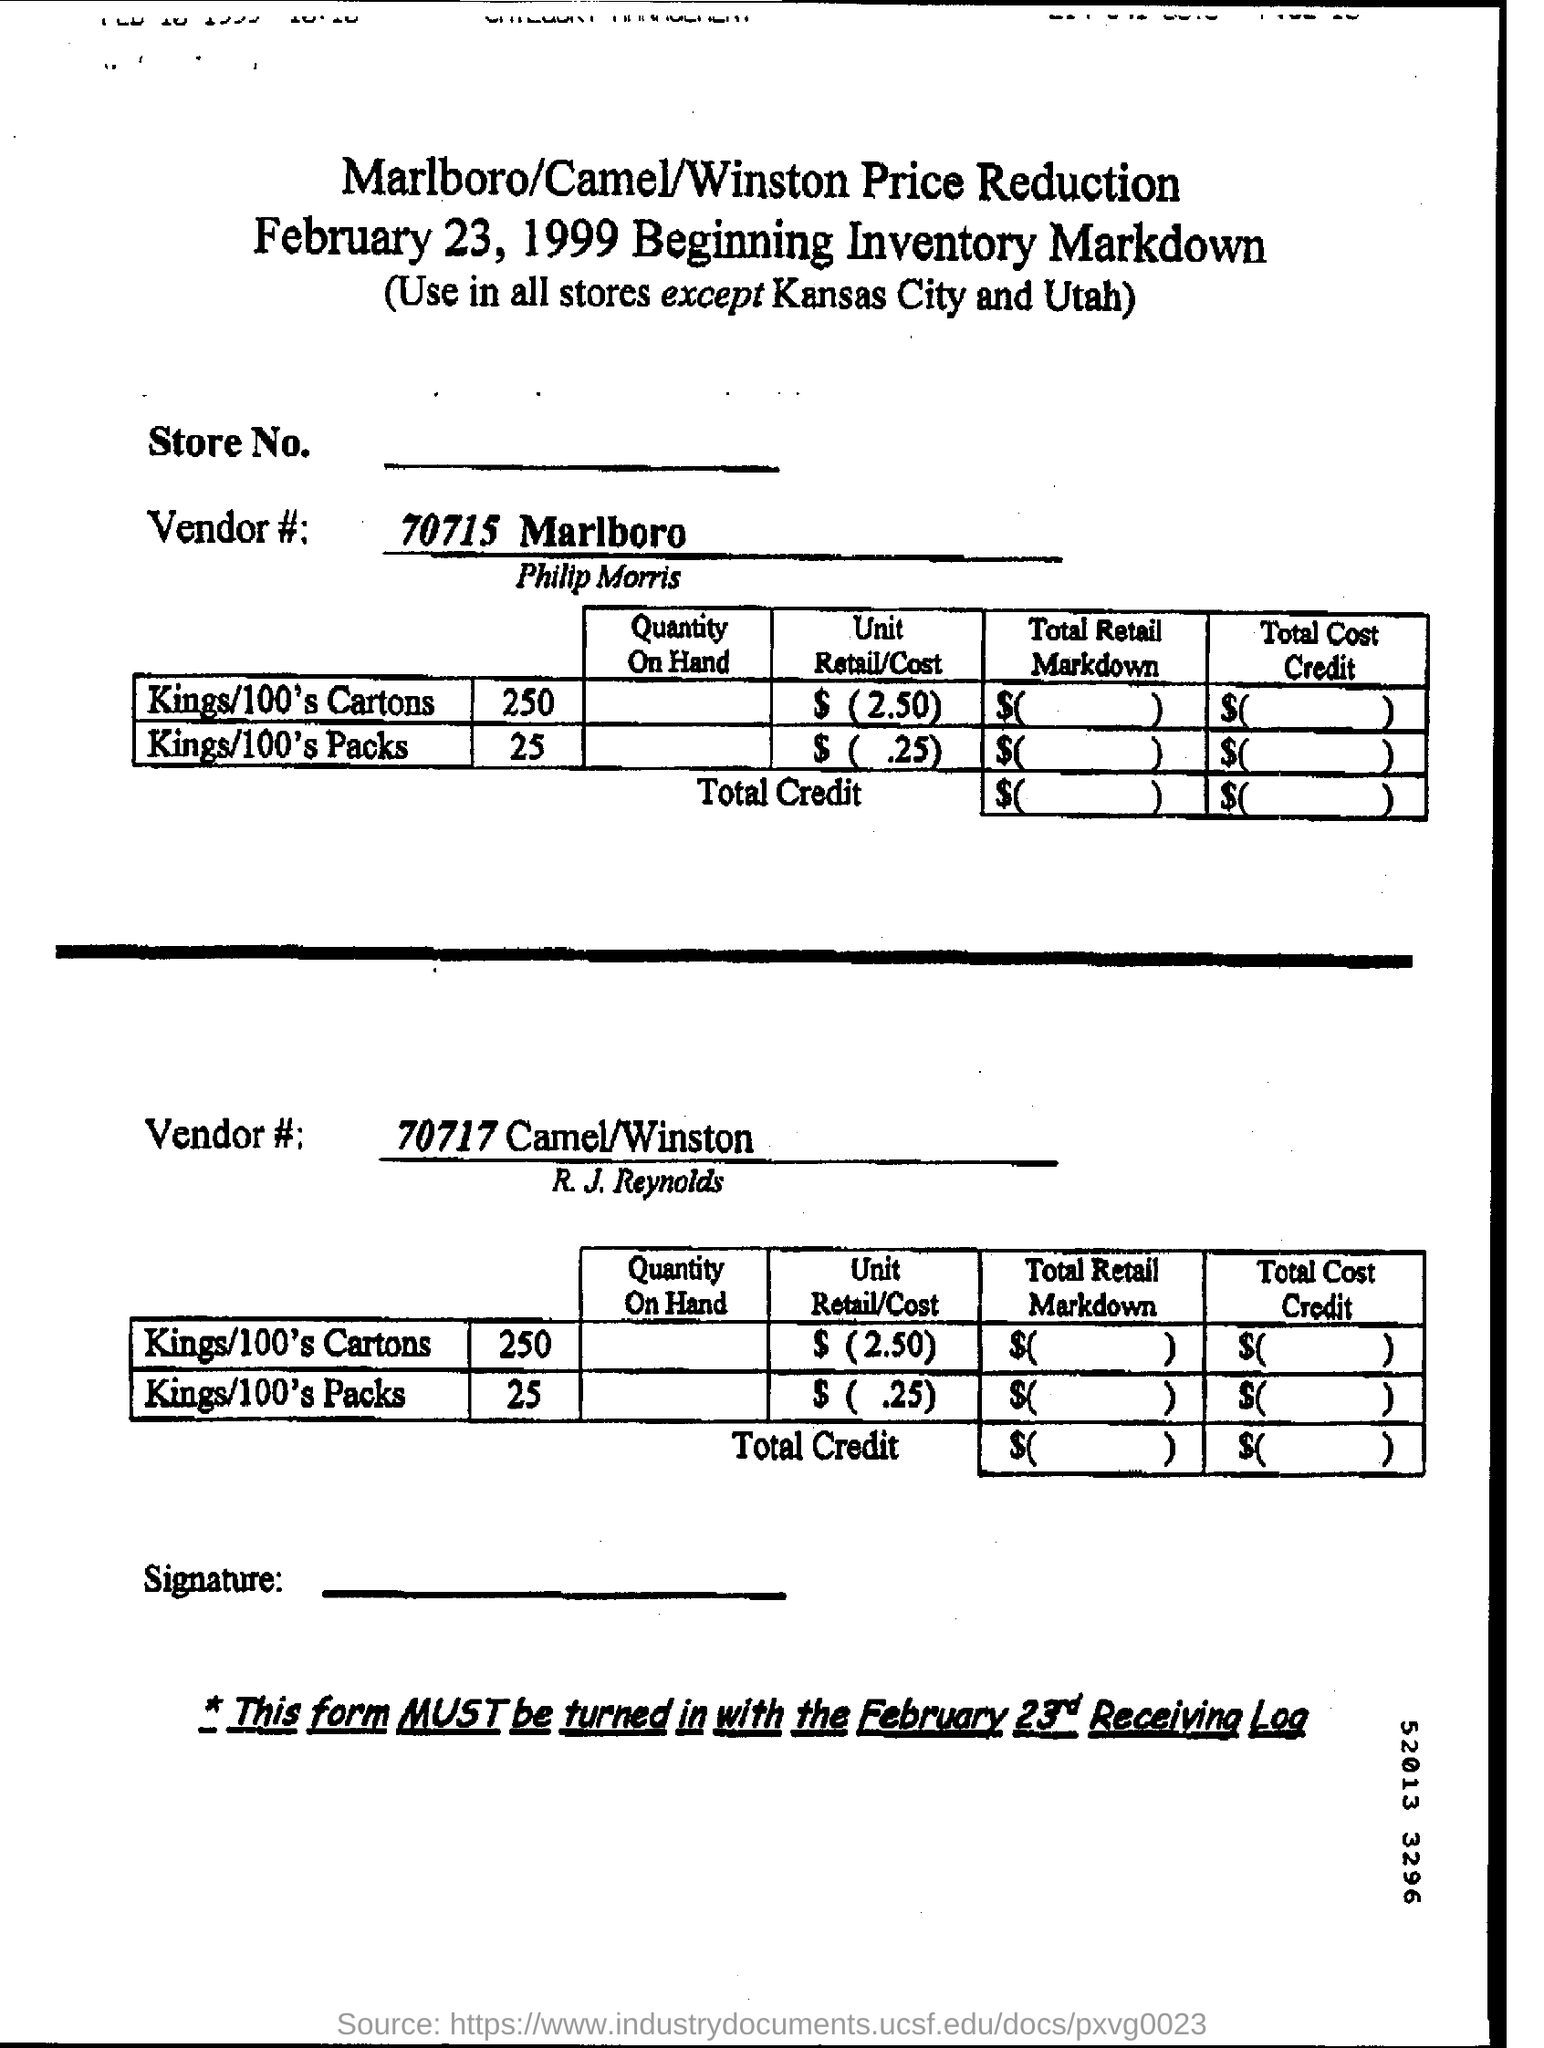Point out several critical features in this image. The beginning inventory markdown form was dated February 23, 1999. 